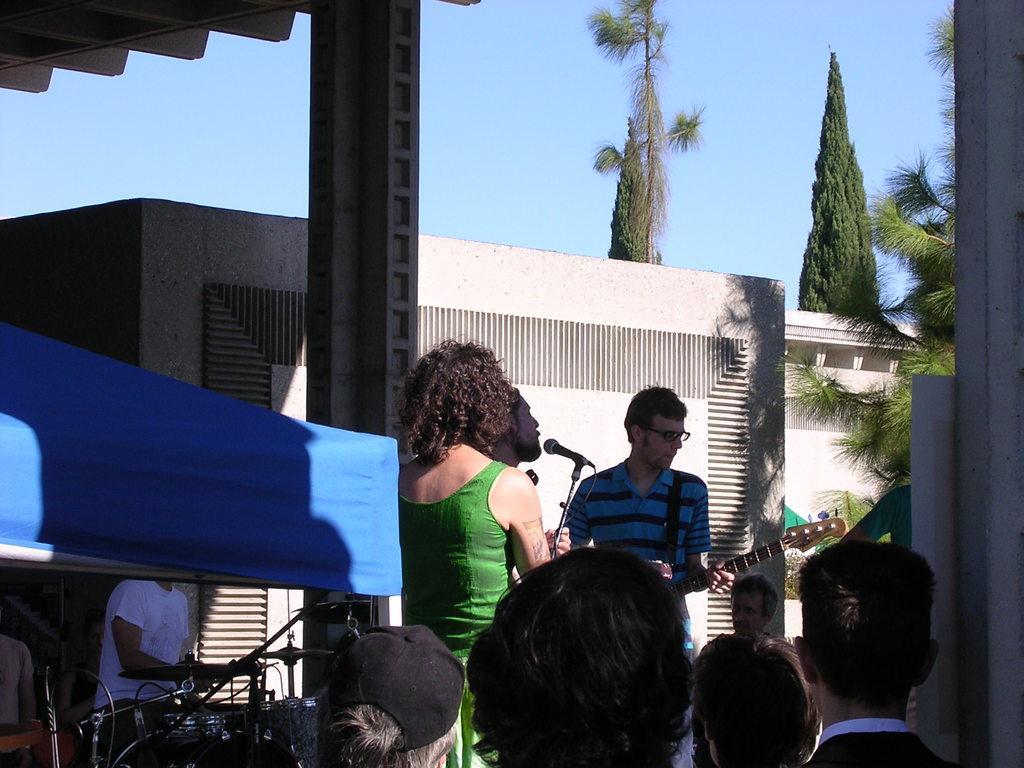How would you summarize this image in a sentence or two? In this image we can see many people. There are few people playing musical instruments. There are many trees and plants in the image. There is a tent and shade in the image. There is a house in the image. 